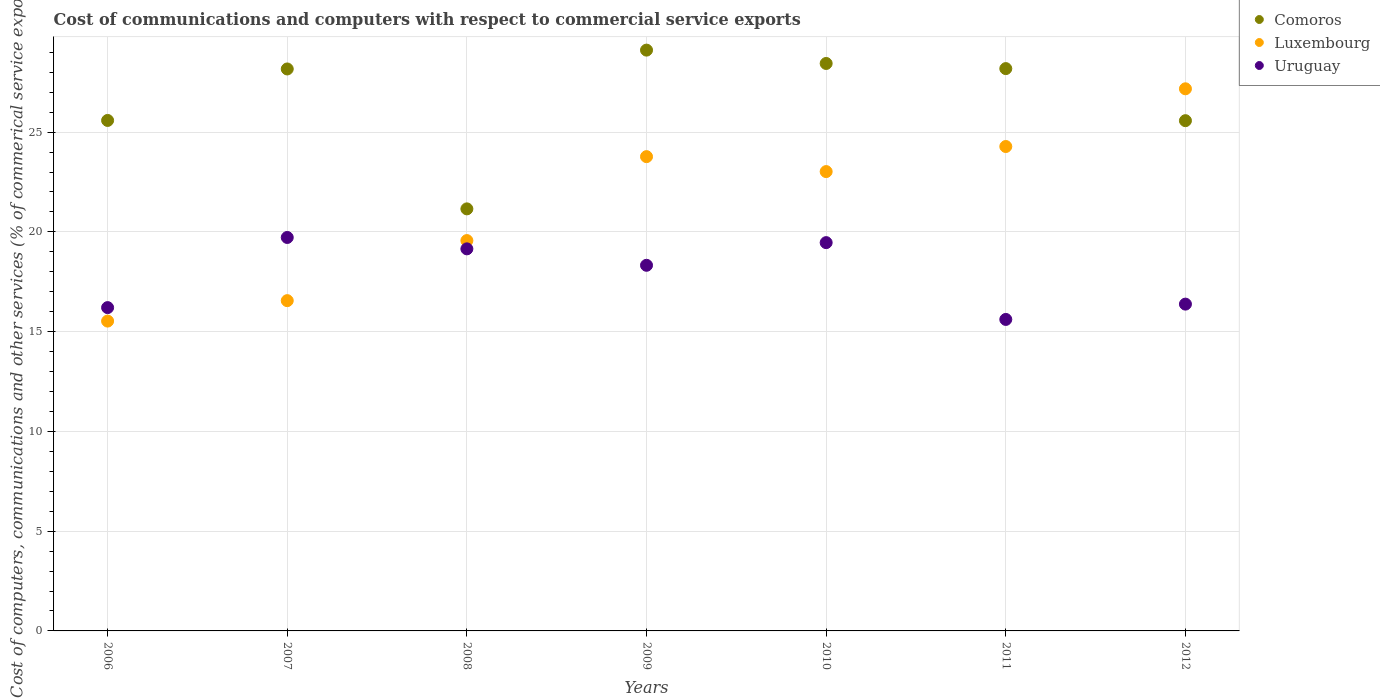What is the cost of communications and computers in Comoros in 2010?
Your answer should be compact. 28.44. Across all years, what is the maximum cost of communications and computers in Luxembourg?
Offer a very short reply. 27.17. Across all years, what is the minimum cost of communications and computers in Luxembourg?
Keep it short and to the point. 15.53. In which year was the cost of communications and computers in Uruguay maximum?
Your response must be concise. 2007. What is the total cost of communications and computers in Luxembourg in the graph?
Provide a short and direct response. 149.89. What is the difference between the cost of communications and computers in Uruguay in 2008 and that in 2011?
Your answer should be very brief. 3.54. What is the difference between the cost of communications and computers in Uruguay in 2009 and the cost of communications and computers in Comoros in 2008?
Provide a short and direct response. -2.83. What is the average cost of communications and computers in Comoros per year?
Your response must be concise. 26.6. In the year 2010, what is the difference between the cost of communications and computers in Uruguay and cost of communications and computers in Luxembourg?
Provide a succinct answer. -3.56. What is the ratio of the cost of communications and computers in Luxembourg in 2011 to that in 2012?
Offer a very short reply. 0.89. Is the cost of communications and computers in Luxembourg in 2011 less than that in 2012?
Make the answer very short. Yes. What is the difference between the highest and the second highest cost of communications and computers in Luxembourg?
Your answer should be very brief. 2.89. What is the difference between the highest and the lowest cost of communications and computers in Luxembourg?
Offer a very short reply. 11.64. Is the sum of the cost of communications and computers in Comoros in 2011 and 2012 greater than the maximum cost of communications and computers in Uruguay across all years?
Keep it short and to the point. Yes. Does the cost of communications and computers in Uruguay monotonically increase over the years?
Your answer should be very brief. No. Is the cost of communications and computers in Comoros strictly greater than the cost of communications and computers in Luxembourg over the years?
Your answer should be very brief. No. Is the cost of communications and computers in Comoros strictly less than the cost of communications and computers in Uruguay over the years?
Make the answer very short. No. How many dotlines are there?
Give a very brief answer. 3. How many years are there in the graph?
Provide a short and direct response. 7. What is the difference between two consecutive major ticks on the Y-axis?
Make the answer very short. 5. Are the values on the major ticks of Y-axis written in scientific E-notation?
Your response must be concise. No. Does the graph contain any zero values?
Provide a succinct answer. No. Where does the legend appear in the graph?
Make the answer very short. Top right. How many legend labels are there?
Give a very brief answer. 3. What is the title of the graph?
Ensure brevity in your answer.  Cost of communications and computers with respect to commercial service exports. What is the label or title of the X-axis?
Provide a succinct answer. Years. What is the label or title of the Y-axis?
Offer a very short reply. Cost of computers, communications and other services (% of commerical service exports). What is the Cost of computers, communications and other services (% of commerical service exports) in Comoros in 2006?
Provide a short and direct response. 25.59. What is the Cost of computers, communications and other services (% of commerical service exports) of Luxembourg in 2006?
Offer a very short reply. 15.53. What is the Cost of computers, communications and other services (% of commerical service exports) in Uruguay in 2006?
Your answer should be very brief. 16.2. What is the Cost of computers, communications and other services (% of commerical service exports) in Comoros in 2007?
Your response must be concise. 28.17. What is the Cost of computers, communications and other services (% of commerical service exports) of Luxembourg in 2007?
Keep it short and to the point. 16.55. What is the Cost of computers, communications and other services (% of commerical service exports) in Uruguay in 2007?
Offer a terse response. 19.72. What is the Cost of computers, communications and other services (% of commerical service exports) of Comoros in 2008?
Provide a short and direct response. 21.15. What is the Cost of computers, communications and other services (% of commerical service exports) of Luxembourg in 2008?
Ensure brevity in your answer.  19.56. What is the Cost of computers, communications and other services (% of commerical service exports) of Uruguay in 2008?
Provide a short and direct response. 19.15. What is the Cost of computers, communications and other services (% of commerical service exports) of Comoros in 2009?
Your answer should be very brief. 29.11. What is the Cost of computers, communications and other services (% of commerical service exports) of Luxembourg in 2009?
Your answer should be compact. 23.77. What is the Cost of computers, communications and other services (% of commerical service exports) in Uruguay in 2009?
Your response must be concise. 18.33. What is the Cost of computers, communications and other services (% of commerical service exports) of Comoros in 2010?
Ensure brevity in your answer.  28.44. What is the Cost of computers, communications and other services (% of commerical service exports) of Luxembourg in 2010?
Provide a succinct answer. 23.02. What is the Cost of computers, communications and other services (% of commerical service exports) of Uruguay in 2010?
Provide a succinct answer. 19.46. What is the Cost of computers, communications and other services (% of commerical service exports) in Comoros in 2011?
Your answer should be compact. 28.18. What is the Cost of computers, communications and other services (% of commerical service exports) of Luxembourg in 2011?
Offer a very short reply. 24.28. What is the Cost of computers, communications and other services (% of commerical service exports) of Uruguay in 2011?
Provide a succinct answer. 15.61. What is the Cost of computers, communications and other services (% of commerical service exports) in Comoros in 2012?
Give a very brief answer. 25.57. What is the Cost of computers, communications and other services (% of commerical service exports) of Luxembourg in 2012?
Provide a short and direct response. 27.17. What is the Cost of computers, communications and other services (% of commerical service exports) of Uruguay in 2012?
Make the answer very short. 16.38. Across all years, what is the maximum Cost of computers, communications and other services (% of commerical service exports) of Comoros?
Your response must be concise. 29.11. Across all years, what is the maximum Cost of computers, communications and other services (% of commerical service exports) in Luxembourg?
Offer a terse response. 27.17. Across all years, what is the maximum Cost of computers, communications and other services (% of commerical service exports) in Uruguay?
Provide a succinct answer. 19.72. Across all years, what is the minimum Cost of computers, communications and other services (% of commerical service exports) in Comoros?
Your answer should be very brief. 21.15. Across all years, what is the minimum Cost of computers, communications and other services (% of commerical service exports) in Luxembourg?
Keep it short and to the point. 15.53. Across all years, what is the minimum Cost of computers, communications and other services (% of commerical service exports) in Uruguay?
Keep it short and to the point. 15.61. What is the total Cost of computers, communications and other services (% of commerical service exports) of Comoros in the graph?
Give a very brief answer. 186.21. What is the total Cost of computers, communications and other services (% of commerical service exports) of Luxembourg in the graph?
Make the answer very short. 149.89. What is the total Cost of computers, communications and other services (% of commerical service exports) of Uruguay in the graph?
Give a very brief answer. 124.85. What is the difference between the Cost of computers, communications and other services (% of commerical service exports) in Comoros in 2006 and that in 2007?
Keep it short and to the point. -2.58. What is the difference between the Cost of computers, communications and other services (% of commerical service exports) of Luxembourg in 2006 and that in 2007?
Your response must be concise. -1.02. What is the difference between the Cost of computers, communications and other services (% of commerical service exports) of Uruguay in 2006 and that in 2007?
Your answer should be very brief. -3.52. What is the difference between the Cost of computers, communications and other services (% of commerical service exports) of Comoros in 2006 and that in 2008?
Give a very brief answer. 4.43. What is the difference between the Cost of computers, communications and other services (% of commerical service exports) in Luxembourg in 2006 and that in 2008?
Offer a very short reply. -4.04. What is the difference between the Cost of computers, communications and other services (% of commerical service exports) of Uruguay in 2006 and that in 2008?
Your answer should be compact. -2.94. What is the difference between the Cost of computers, communications and other services (% of commerical service exports) in Comoros in 2006 and that in 2009?
Give a very brief answer. -3.52. What is the difference between the Cost of computers, communications and other services (% of commerical service exports) in Luxembourg in 2006 and that in 2009?
Offer a terse response. -8.24. What is the difference between the Cost of computers, communications and other services (% of commerical service exports) of Uruguay in 2006 and that in 2009?
Offer a terse response. -2.12. What is the difference between the Cost of computers, communications and other services (% of commerical service exports) in Comoros in 2006 and that in 2010?
Your answer should be compact. -2.86. What is the difference between the Cost of computers, communications and other services (% of commerical service exports) of Luxembourg in 2006 and that in 2010?
Your answer should be very brief. -7.49. What is the difference between the Cost of computers, communications and other services (% of commerical service exports) in Uruguay in 2006 and that in 2010?
Give a very brief answer. -3.26. What is the difference between the Cost of computers, communications and other services (% of commerical service exports) of Comoros in 2006 and that in 2011?
Provide a succinct answer. -2.6. What is the difference between the Cost of computers, communications and other services (% of commerical service exports) of Luxembourg in 2006 and that in 2011?
Your answer should be very brief. -8.75. What is the difference between the Cost of computers, communications and other services (% of commerical service exports) of Uruguay in 2006 and that in 2011?
Offer a terse response. 0.59. What is the difference between the Cost of computers, communications and other services (% of commerical service exports) of Comoros in 2006 and that in 2012?
Provide a succinct answer. 0.01. What is the difference between the Cost of computers, communications and other services (% of commerical service exports) of Luxembourg in 2006 and that in 2012?
Ensure brevity in your answer.  -11.64. What is the difference between the Cost of computers, communications and other services (% of commerical service exports) of Uruguay in 2006 and that in 2012?
Ensure brevity in your answer.  -0.17. What is the difference between the Cost of computers, communications and other services (% of commerical service exports) in Comoros in 2007 and that in 2008?
Provide a succinct answer. 7.01. What is the difference between the Cost of computers, communications and other services (% of commerical service exports) of Luxembourg in 2007 and that in 2008?
Offer a terse response. -3.01. What is the difference between the Cost of computers, communications and other services (% of commerical service exports) in Uruguay in 2007 and that in 2008?
Ensure brevity in your answer.  0.57. What is the difference between the Cost of computers, communications and other services (% of commerical service exports) of Comoros in 2007 and that in 2009?
Your response must be concise. -0.94. What is the difference between the Cost of computers, communications and other services (% of commerical service exports) of Luxembourg in 2007 and that in 2009?
Provide a short and direct response. -7.22. What is the difference between the Cost of computers, communications and other services (% of commerical service exports) in Uruguay in 2007 and that in 2009?
Offer a very short reply. 1.39. What is the difference between the Cost of computers, communications and other services (% of commerical service exports) of Comoros in 2007 and that in 2010?
Keep it short and to the point. -0.28. What is the difference between the Cost of computers, communications and other services (% of commerical service exports) of Luxembourg in 2007 and that in 2010?
Provide a succinct answer. -6.47. What is the difference between the Cost of computers, communications and other services (% of commerical service exports) of Uruguay in 2007 and that in 2010?
Offer a terse response. 0.26. What is the difference between the Cost of computers, communications and other services (% of commerical service exports) in Comoros in 2007 and that in 2011?
Keep it short and to the point. -0.02. What is the difference between the Cost of computers, communications and other services (% of commerical service exports) in Luxembourg in 2007 and that in 2011?
Keep it short and to the point. -7.73. What is the difference between the Cost of computers, communications and other services (% of commerical service exports) in Uruguay in 2007 and that in 2011?
Give a very brief answer. 4.11. What is the difference between the Cost of computers, communications and other services (% of commerical service exports) in Comoros in 2007 and that in 2012?
Your response must be concise. 2.59. What is the difference between the Cost of computers, communications and other services (% of commerical service exports) of Luxembourg in 2007 and that in 2012?
Make the answer very short. -10.62. What is the difference between the Cost of computers, communications and other services (% of commerical service exports) in Uruguay in 2007 and that in 2012?
Offer a terse response. 3.34. What is the difference between the Cost of computers, communications and other services (% of commerical service exports) of Comoros in 2008 and that in 2009?
Give a very brief answer. -7.96. What is the difference between the Cost of computers, communications and other services (% of commerical service exports) in Luxembourg in 2008 and that in 2009?
Offer a terse response. -4.21. What is the difference between the Cost of computers, communications and other services (% of commerical service exports) of Uruguay in 2008 and that in 2009?
Offer a terse response. 0.82. What is the difference between the Cost of computers, communications and other services (% of commerical service exports) of Comoros in 2008 and that in 2010?
Provide a succinct answer. -7.29. What is the difference between the Cost of computers, communications and other services (% of commerical service exports) of Luxembourg in 2008 and that in 2010?
Ensure brevity in your answer.  -3.46. What is the difference between the Cost of computers, communications and other services (% of commerical service exports) in Uruguay in 2008 and that in 2010?
Your answer should be very brief. -0.31. What is the difference between the Cost of computers, communications and other services (% of commerical service exports) of Comoros in 2008 and that in 2011?
Keep it short and to the point. -7.03. What is the difference between the Cost of computers, communications and other services (% of commerical service exports) of Luxembourg in 2008 and that in 2011?
Make the answer very short. -4.71. What is the difference between the Cost of computers, communications and other services (% of commerical service exports) of Uruguay in 2008 and that in 2011?
Your answer should be very brief. 3.54. What is the difference between the Cost of computers, communications and other services (% of commerical service exports) of Comoros in 2008 and that in 2012?
Make the answer very short. -4.42. What is the difference between the Cost of computers, communications and other services (% of commerical service exports) of Luxembourg in 2008 and that in 2012?
Your response must be concise. -7.61. What is the difference between the Cost of computers, communications and other services (% of commerical service exports) in Uruguay in 2008 and that in 2012?
Make the answer very short. 2.77. What is the difference between the Cost of computers, communications and other services (% of commerical service exports) of Comoros in 2009 and that in 2010?
Provide a succinct answer. 0.67. What is the difference between the Cost of computers, communications and other services (% of commerical service exports) of Luxembourg in 2009 and that in 2010?
Your response must be concise. 0.75. What is the difference between the Cost of computers, communications and other services (% of commerical service exports) of Uruguay in 2009 and that in 2010?
Your answer should be compact. -1.14. What is the difference between the Cost of computers, communications and other services (% of commerical service exports) in Comoros in 2009 and that in 2011?
Your response must be concise. 0.93. What is the difference between the Cost of computers, communications and other services (% of commerical service exports) of Luxembourg in 2009 and that in 2011?
Your answer should be very brief. -0.51. What is the difference between the Cost of computers, communications and other services (% of commerical service exports) in Uruguay in 2009 and that in 2011?
Your response must be concise. 2.71. What is the difference between the Cost of computers, communications and other services (% of commerical service exports) in Comoros in 2009 and that in 2012?
Offer a very short reply. 3.54. What is the difference between the Cost of computers, communications and other services (% of commerical service exports) in Luxembourg in 2009 and that in 2012?
Offer a very short reply. -3.4. What is the difference between the Cost of computers, communications and other services (% of commerical service exports) of Uruguay in 2009 and that in 2012?
Your answer should be very brief. 1.95. What is the difference between the Cost of computers, communications and other services (% of commerical service exports) of Comoros in 2010 and that in 2011?
Ensure brevity in your answer.  0.26. What is the difference between the Cost of computers, communications and other services (% of commerical service exports) of Luxembourg in 2010 and that in 2011?
Provide a short and direct response. -1.26. What is the difference between the Cost of computers, communications and other services (% of commerical service exports) in Uruguay in 2010 and that in 2011?
Provide a short and direct response. 3.85. What is the difference between the Cost of computers, communications and other services (% of commerical service exports) of Comoros in 2010 and that in 2012?
Offer a very short reply. 2.87. What is the difference between the Cost of computers, communications and other services (% of commerical service exports) of Luxembourg in 2010 and that in 2012?
Keep it short and to the point. -4.15. What is the difference between the Cost of computers, communications and other services (% of commerical service exports) in Uruguay in 2010 and that in 2012?
Offer a terse response. 3.08. What is the difference between the Cost of computers, communications and other services (% of commerical service exports) of Comoros in 2011 and that in 2012?
Make the answer very short. 2.61. What is the difference between the Cost of computers, communications and other services (% of commerical service exports) in Luxembourg in 2011 and that in 2012?
Give a very brief answer. -2.89. What is the difference between the Cost of computers, communications and other services (% of commerical service exports) in Uruguay in 2011 and that in 2012?
Offer a very short reply. -0.77. What is the difference between the Cost of computers, communications and other services (% of commerical service exports) of Comoros in 2006 and the Cost of computers, communications and other services (% of commerical service exports) of Luxembourg in 2007?
Offer a terse response. 9.03. What is the difference between the Cost of computers, communications and other services (% of commerical service exports) of Comoros in 2006 and the Cost of computers, communications and other services (% of commerical service exports) of Uruguay in 2007?
Make the answer very short. 5.87. What is the difference between the Cost of computers, communications and other services (% of commerical service exports) in Luxembourg in 2006 and the Cost of computers, communications and other services (% of commerical service exports) in Uruguay in 2007?
Offer a terse response. -4.19. What is the difference between the Cost of computers, communications and other services (% of commerical service exports) in Comoros in 2006 and the Cost of computers, communications and other services (% of commerical service exports) in Luxembourg in 2008?
Your response must be concise. 6.02. What is the difference between the Cost of computers, communications and other services (% of commerical service exports) of Comoros in 2006 and the Cost of computers, communications and other services (% of commerical service exports) of Uruguay in 2008?
Ensure brevity in your answer.  6.44. What is the difference between the Cost of computers, communications and other services (% of commerical service exports) of Luxembourg in 2006 and the Cost of computers, communications and other services (% of commerical service exports) of Uruguay in 2008?
Provide a short and direct response. -3.62. What is the difference between the Cost of computers, communications and other services (% of commerical service exports) of Comoros in 2006 and the Cost of computers, communications and other services (% of commerical service exports) of Luxembourg in 2009?
Give a very brief answer. 1.81. What is the difference between the Cost of computers, communications and other services (% of commerical service exports) of Comoros in 2006 and the Cost of computers, communications and other services (% of commerical service exports) of Uruguay in 2009?
Provide a succinct answer. 7.26. What is the difference between the Cost of computers, communications and other services (% of commerical service exports) in Luxembourg in 2006 and the Cost of computers, communications and other services (% of commerical service exports) in Uruguay in 2009?
Provide a short and direct response. -2.8. What is the difference between the Cost of computers, communications and other services (% of commerical service exports) in Comoros in 2006 and the Cost of computers, communications and other services (% of commerical service exports) in Luxembourg in 2010?
Your response must be concise. 2.56. What is the difference between the Cost of computers, communications and other services (% of commerical service exports) of Comoros in 2006 and the Cost of computers, communications and other services (% of commerical service exports) of Uruguay in 2010?
Keep it short and to the point. 6.12. What is the difference between the Cost of computers, communications and other services (% of commerical service exports) in Luxembourg in 2006 and the Cost of computers, communications and other services (% of commerical service exports) in Uruguay in 2010?
Ensure brevity in your answer.  -3.93. What is the difference between the Cost of computers, communications and other services (% of commerical service exports) in Comoros in 2006 and the Cost of computers, communications and other services (% of commerical service exports) in Luxembourg in 2011?
Ensure brevity in your answer.  1.31. What is the difference between the Cost of computers, communications and other services (% of commerical service exports) in Comoros in 2006 and the Cost of computers, communications and other services (% of commerical service exports) in Uruguay in 2011?
Keep it short and to the point. 9.97. What is the difference between the Cost of computers, communications and other services (% of commerical service exports) in Luxembourg in 2006 and the Cost of computers, communications and other services (% of commerical service exports) in Uruguay in 2011?
Provide a short and direct response. -0.08. What is the difference between the Cost of computers, communications and other services (% of commerical service exports) in Comoros in 2006 and the Cost of computers, communications and other services (% of commerical service exports) in Luxembourg in 2012?
Provide a succinct answer. -1.59. What is the difference between the Cost of computers, communications and other services (% of commerical service exports) in Comoros in 2006 and the Cost of computers, communications and other services (% of commerical service exports) in Uruguay in 2012?
Make the answer very short. 9.21. What is the difference between the Cost of computers, communications and other services (% of commerical service exports) in Luxembourg in 2006 and the Cost of computers, communications and other services (% of commerical service exports) in Uruguay in 2012?
Your answer should be compact. -0.85. What is the difference between the Cost of computers, communications and other services (% of commerical service exports) in Comoros in 2007 and the Cost of computers, communications and other services (% of commerical service exports) in Luxembourg in 2008?
Give a very brief answer. 8.6. What is the difference between the Cost of computers, communications and other services (% of commerical service exports) of Comoros in 2007 and the Cost of computers, communications and other services (% of commerical service exports) of Uruguay in 2008?
Ensure brevity in your answer.  9.02. What is the difference between the Cost of computers, communications and other services (% of commerical service exports) of Luxembourg in 2007 and the Cost of computers, communications and other services (% of commerical service exports) of Uruguay in 2008?
Your answer should be very brief. -2.6. What is the difference between the Cost of computers, communications and other services (% of commerical service exports) of Comoros in 2007 and the Cost of computers, communications and other services (% of commerical service exports) of Luxembourg in 2009?
Make the answer very short. 4.39. What is the difference between the Cost of computers, communications and other services (% of commerical service exports) of Comoros in 2007 and the Cost of computers, communications and other services (% of commerical service exports) of Uruguay in 2009?
Your response must be concise. 9.84. What is the difference between the Cost of computers, communications and other services (% of commerical service exports) of Luxembourg in 2007 and the Cost of computers, communications and other services (% of commerical service exports) of Uruguay in 2009?
Your answer should be compact. -1.77. What is the difference between the Cost of computers, communications and other services (% of commerical service exports) in Comoros in 2007 and the Cost of computers, communications and other services (% of commerical service exports) in Luxembourg in 2010?
Make the answer very short. 5.14. What is the difference between the Cost of computers, communications and other services (% of commerical service exports) in Comoros in 2007 and the Cost of computers, communications and other services (% of commerical service exports) in Uruguay in 2010?
Give a very brief answer. 8.7. What is the difference between the Cost of computers, communications and other services (% of commerical service exports) in Luxembourg in 2007 and the Cost of computers, communications and other services (% of commerical service exports) in Uruguay in 2010?
Provide a short and direct response. -2.91. What is the difference between the Cost of computers, communications and other services (% of commerical service exports) of Comoros in 2007 and the Cost of computers, communications and other services (% of commerical service exports) of Luxembourg in 2011?
Keep it short and to the point. 3.89. What is the difference between the Cost of computers, communications and other services (% of commerical service exports) of Comoros in 2007 and the Cost of computers, communications and other services (% of commerical service exports) of Uruguay in 2011?
Your answer should be very brief. 12.55. What is the difference between the Cost of computers, communications and other services (% of commerical service exports) of Luxembourg in 2007 and the Cost of computers, communications and other services (% of commerical service exports) of Uruguay in 2011?
Keep it short and to the point. 0.94. What is the difference between the Cost of computers, communications and other services (% of commerical service exports) of Comoros in 2007 and the Cost of computers, communications and other services (% of commerical service exports) of Uruguay in 2012?
Make the answer very short. 11.79. What is the difference between the Cost of computers, communications and other services (% of commerical service exports) of Luxembourg in 2007 and the Cost of computers, communications and other services (% of commerical service exports) of Uruguay in 2012?
Your answer should be compact. 0.17. What is the difference between the Cost of computers, communications and other services (% of commerical service exports) of Comoros in 2008 and the Cost of computers, communications and other services (% of commerical service exports) of Luxembourg in 2009?
Keep it short and to the point. -2.62. What is the difference between the Cost of computers, communications and other services (% of commerical service exports) in Comoros in 2008 and the Cost of computers, communications and other services (% of commerical service exports) in Uruguay in 2009?
Provide a succinct answer. 2.83. What is the difference between the Cost of computers, communications and other services (% of commerical service exports) of Luxembourg in 2008 and the Cost of computers, communications and other services (% of commerical service exports) of Uruguay in 2009?
Ensure brevity in your answer.  1.24. What is the difference between the Cost of computers, communications and other services (% of commerical service exports) of Comoros in 2008 and the Cost of computers, communications and other services (% of commerical service exports) of Luxembourg in 2010?
Ensure brevity in your answer.  -1.87. What is the difference between the Cost of computers, communications and other services (% of commerical service exports) of Comoros in 2008 and the Cost of computers, communications and other services (% of commerical service exports) of Uruguay in 2010?
Your answer should be very brief. 1.69. What is the difference between the Cost of computers, communications and other services (% of commerical service exports) of Luxembourg in 2008 and the Cost of computers, communications and other services (% of commerical service exports) of Uruguay in 2010?
Provide a succinct answer. 0.1. What is the difference between the Cost of computers, communications and other services (% of commerical service exports) in Comoros in 2008 and the Cost of computers, communications and other services (% of commerical service exports) in Luxembourg in 2011?
Your response must be concise. -3.13. What is the difference between the Cost of computers, communications and other services (% of commerical service exports) of Comoros in 2008 and the Cost of computers, communications and other services (% of commerical service exports) of Uruguay in 2011?
Give a very brief answer. 5.54. What is the difference between the Cost of computers, communications and other services (% of commerical service exports) in Luxembourg in 2008 and the Cost of computers, communications and other services (% of commerical service exports) in Uruguay in 2011?
Give a very brief answer. 3.95. What is the difference between the Cost of computers, communications and other services (% of commerical service exports) of Comoros in 2008 and the Cost of computers, communications and other services (% of commerical service exports) of Luxembourg in 2012?
Offer a very short reply. -6.02. What is the difference between the Cost of computers, communications and other services (% of commerical service exports) of Comoros in 2008 and the Cost of computers, communications and other services (% of commerical service exports) of Uruguay in 2012?
Offer a terse response. 4.77. What is the difference between the Cost of computers, communications and other services (% of commerical service exports) of Luxembourg in 2008 and the Cost of computers, communications and other services (% of commerical service exports) of Uruguay in 2012?
Offer a very short reply. 3.19. What is the difference between the Cost of computers, communications and other services (% of commerical service exports) of Comoros in 2009 and the Cost of computers, communications and other services (% of commerical service exports) of Luxembourg in 2010?
Your answer should be compact. 6.09. What is the difference between the Cost of computers, communications and other services (% of commerical service exports) of Comoros in 2009 and the Cost of computers, communications and other services (% of commerical service exports) of Uruguay in 2010?
Provide a succinct answer. 9.65. What is the difference between the Cost of computers, communications and other services (% of commerical service exports) in Luxembourg in 2009 and the Cost of computers, communications and other services (% of commerical service exports) in Uruguay in 2010?
Your response must be concise. 4.31. What is the difference between the Cost of computers, communications and other services (% of commerical service exports) of Comoros in 2009 and the Cost of computers, communications and other services (% of commerical service exports) of Luxembourg in 2011?
Provide a short and direct response. 4.83. What is the difference between the Cost of computers, communications and other services (% of commerical service exports) of Comoros in 2009 and the Cost of computers, communications and other services (% of commerical service exports) of Uruguay in 2011?
Offer a terse response. 13.5. What is the difference between the Cost of computers, communications and other services (% of commerical service exports) of Luxembourg in 2009 and the Cost of computers, communications and other services (% of commerical service exports) of Uruguay in 2011?
Keep it short and to the point. 8.16. What is the difference between the Cost of computers, communications and other services (% of commerical service exports) of Comoros in 2009 and the Cost of computers, communications and other services (% of commerical service exports) of Luxembourg in 2012?
Offer a very short reply. 1.94. What is the difference between the Cost of computers, communications and other services (% of commerical service exports) of Comoros in 2009 and the Cost of computers, communications and other services (% of commerical service exports) of Uruguay in 2012?
Ensure brevity in your answer.  12.73. What is the difference between the Cost of computers, communications and other services (% of commerical service exports) in Luxembourg in 2009 and the Cost of computers, communications and other services (% of commerical service exports) in Uruguay in 2012?
Offer a terse response. 7.39. What is the difference between the Cost of computers, communications and other services (% of commerical service exports) of Comoros in 2010 and the Cost of computers, communications and other services (% of commerical service exports) of Luxembourg in 2011?
Ensure brevity in your answer.  4.16. What is the difference between the Cost of computers, communications and other services (% of commerical service exports) of Comoros in 2010 and the Cost of computers, communications and other services (% of commerical service exports) of Uruguay in 2011?
Provide a succinct answer. 12.83. What is the difference between the Cost of computers, communications and other services (% of commerical service exports) in Luxembourg in 2010 and the Cost of computers, communications and other services (% of commerical service exports) in Uruguay in 2011?
Your answer should be very brief. 7.41. What is the difference between the Cost of computers, communications and other services (% of commerical service exports) in Comoros in 2010 and the Cost of computers, communications and other services (% of commerical service exports) in Luxembourg in 2012?
Your answer should be very brief. 1.27. What is the difference between the Cost of computers, communications and other services (% of commerical service exports) in Comoros in 2010 and the Cost of computers, communications and other services (% of commerical service exports) in Uruguay in 2012?
Your answer should be compact. 12.06. What is the difference between the Cost of computers, communications and other services (% of commerical service exports) in Luxembourg in 2010 and the Cost of computers, communications and other services (% of commerical service exports) in Uruguay in 2012?
Your answer should be very brief. 6.64. What is the difference between the Cost of computers, communications and other services (% of commerical service exports) of Comoros in 2011 and the Cost of computers, communications and other services (% of commerical service exports) of Luxembourg in 2012?
Your response must be concise. 1.01. What is the difference between the Cost of computers, communications and other services (% of commerical service exports) of Comoros in 2011 and the Cost of computers, communications and other services (% of commerical service exports) of Uruguay in 2012?
Offer a very short reply. 11.8. What is the difference between the Cost of computers, communications and other services (% of commerical service exports) in Luxembourg in 2011 and the Cost of computers, communications and other services (% of commerical service exports) in Uruguay in 2012?
Your response must be concise. 7.9. What is the average Cost of computers, communications and other services (% of commerical service exports) of Comoros per year?
Offer a terse response. 26.6. What is the average Cost of computers, communications and other services (% of commerical service exports) in Luxembourg per year?
Your answer should be very brief. 21.41. What is the average Cost of computers, communications and other services (% of commerical service exports) in Uruguay per year?
Your response must be concise. 17.84. In the year 2006, what is the difference between the Cost of computers, communications and other services (% of commerical service exports) of Comoros and Cost of computers, communications and other services (% of commerical service exports) of Luxembourg?
Keep it short and to the point. 10.06. In the year 2006, what is the difference between the Cost of computers, communications and other services (% of commerical service exports) in Comoros and Cost of computers, communications and other services (% of commerical service exports) in Uruguay?
Offer a terse response. 9.38. In the year 2006, what is the difference between the Cost of computers, communications and other services (% of commerical service exports) in Luxembourg and Cost of computers, communications and other services (% of commerical service exports) in Uruguay?
Your answer should be very brief. -0.68. In the year 2007, what is the difference between the Cost of computers, communications and other services (% of commerical service exports) of Comoros and Cost of computers, communications and other services (% of commerical service exports) of Luxembourg?
Provide a succinct answer. 11.61. In the year 2007, what is the difference between the Cost of computers, communications and other services (% of commerical service exports) in Comoros and Cost of computers, communications and other services (% of commerical service exports) in Uruguay?
Your answer should be very brief. 8.45. In the year 2007, what is the difference between the Cost of computers, communications and other services (% of commerical service exports) in Luxembourg and Cost of computers, communications and other services (% of commerical service exports) in Uruguay?
Provide a succinct answer. -3.17. In the year 2008, what is the difference between the Cost of computers, communications and other services (% of commerical service exports) of Comoros and Cost of computers, communications and other services (% of commerical service exports) of Luxembourg?
Your answer should be compact. 1.59. In the year 2008, what is the difference between the Cost of computers, communications and other services (% of commerical service exports) of Comoros and Cost of computers, communications and other services (% of commerical service exports) of Uruguay?
Offer a terse response. 2. In the year 2008, what is the difference between the Cost of computers, communications and other services (% of commerical service exports) in Luxembourg and Cost of computers, communications and other services (% of commerical service exports) in Uruguay?
Your answer should be very brief. 0.41. In the year 2009, what is the difference between the Cost of computers, communications and other services (% of commerical service exports) in Comoros and Cost of computers, communications and other services (% of commerical service exports) in Luxembourg?
Keep it short and to the point. 5.34. In the year 2009, what is the difference between the Cost of computers, communications and other services (% of commerical service exports) in Comoros and Cost of computers, communications and other services (% of commerical service exports) in Uruguay?
Keep it short and to the point. 10.78. In the year 2009, what is the difference between the Cost of computers, communications and other services (% of commerical service exports) in Luxembourg and Cost of computers, communications and other services (% of commerical service exports) in Uruguay?
Your response must be concise. 5.45. In the year 2010, what is the difference between the Cost of computers, communications and other services (% of commerical service exports) in Comoros and Cost of computers, communications and other services (% of commerical service exports) in Luxembourg?
Your response must be concise. 5.42. In the year 2010, what is the difference between the Cost of computers, communications and other services (% of commerical service exports) of Comoros and Cost of computers, communications and other services (% of commerical service exports) of Uruguay?
Your answer should be very brief. 8.98. In the year 2010, what is the difference between the Cost of computers, communications and other services (% of commerical service exports) in Luxembourg and Cost of computers, communications and other services (% of commerical service exports) in Uruguay?
Your answer should be very brief. 3.56. In the year 2011, what is the difference between the Cost of computers, communications and other services (% of commerical service exports) of Comoros and Cost of computers, communications and other services (% of commerical service exports) of Luxembourg?
Give a very brief answer. 3.9. In the year 2011, what is the difference between the Cost of computers, communications and other services (% of commerical service exports) in Comoros and Cost of computers, communications and other services (% of commerical service exports) in Uruguay?
Provide a short and direct response. 12.57. In the year 2011, what is the difference between the Cost of computers, communications and other services (% of commerical service exports) of Luxembourg and Cost of computers, communications and other services (% of commerical service exports) of Uruguay?
Your answer should be compact. 8.67. In the year 2012, what is the difference between the Cost of computers, communications and other services (% of commerical service exports) in Comoros and Cost of computers, communications and other services (% of commerical service exports) in Luxembourg?
Ensure brevity in your answer.  -1.6. In the year 2012, what is the difference between the Cost of computers, communications and other services (% of commerical service exports) in Comoros and Cost of computers, communications and other services (% of commerical service exports) in Uruguay?
Keep it short and to the point. 9.19. In the year 2012, what is the difference between the Cost of computers, communications and other services (% of commerical service exports) of Luxembourg and Cost of computers, communications and other services (% of commerical service exports) of Uruguay?
Keep it short and to the point. 10.79. What is the ratio of the Cost of computers, communications and other services (% of commerical service exports) of Comoros in 2006 to that in 2007?
Your response must be concise. 0.91. What is the ratio of the Cost of computers, communications and other services (% of commerical service exports) of Luxembourg in 2006 to that in 2007?
Your answer should be very brief. 0.94. What is the ratio of the Cost of computers, communications and other services (% of commerical service exports) of Uruguay in 2006 to that in 2007?
Your answer should be very brief. 0.82. What is the ratio of the Cost of computers, communications and other services (% of commerical service exports) in Comoros in 2006 to that in 2008?
Keep it short and to the point. 1.21. What is the ratio of the Cost of computers, communications and other services (% of commerical service exports) in Luxembourg in 2006 to that in 2008?
Offer a terse response. 0.79. What is the ratio of the Cost of computers, communications and other services (% of commerical service exports) in Uruguay in 2006 to that in 2008?
Give a very brief answer. 0.85. What is the ratio of the Cost of computers, communications and other services (% of commerical service exports) in Comoros in 2006 to that in 2009?
Your answer should be very brief. 0.88. What is the ratio of the Cost of computers, communications and other services (% of commerical service exports) of Luxembourg in 2006 to that in 2009?
Give a very brief answer. 0.65. What is the ratio of the Cost of computers, communications and other services (% of commerical service exports) in Uruguay in 2006 to that in 2009?
Provide a short and direct response. 0.88. What is the ratio of the Cost of computers, communications and other services (% of commerical service exports) of Comoros in 2006 to that in 2010?
Your answer should be very brief. 0.9. What is the ratio of the Cost of computers, communications and other services (% of commerical service exports) in Luxembourg in 2006 to that in 2010?
Your answer should be compact. 0.67. What is the ratio of the Cost of computers, communications and other services (% of commerical service exports) in Uruguay in 2006 to that in 2010?
Your response must be concise. 0.83. What is the ratio of the Cost of computers, communications and other services (% of commerical service exports) in Comoros in 2006 to that in 2011?
Give a very brief answer. 0.91. What is the ratio of the Cost of computers, communications and other services (% of commerical service exports) in Luxembourg in 2006 to that in 2011?
Ensure brevity in your answer.  0.64. What is the ratio of the Cost of computers, communications and other services (% of commerical service exports) of Uruguay in 2006 to that in 2011?
Offer a terse response. 1.04. What is the ratio of the Cost of computers, communications and other services (% of commerical service exports) of Comoros in 2006 to that in 2012?
Give a very brief answer. 1. What is the ratio of the Cost of computers, communications and other services (% of commerical service exports) in Luxembourg in 2006 to that in 2012?
Your response must be concise. 0.57. What is the ratio of the Cost of computers, communications and other services (% of commerical service exports) of Uruguay in 2006 to that in 2012?
Make the answer very short. 0.99. What is the ratio of the Cost of computers, communications and other services (% of commerical service exports) in Comoros in 2007 to that in 2008?
Keep it short and to the point. 1.33. What is the ratio of the Cost of computers, communications and other services (% of commerical service exports) of Luxembourg in 2007 to that in 2008?
Keep it short and to the point. 0.85. What is the ratio of the Cost of computers, communications and other services (% of commerical service exports) of Uruguay in 2007 to that in 2008?
Provide a short and direct response. 1.03. What is the ratio of the Cost of computers, communications and other services (% of commerical service exports) in Comoros in 2007 to that in 2009?
Keep it short and to the point. 0.97. What is the ratio of the Cost of computers, communications and other services (% of commerical service exports) in Luxembourg in 2007 to that in 2009?
Provide a short and direct response. 0.7. What is the ratio of the Cost of computers, communications and other services (% of commerical service exports) of Uruguay in 2007 to that in 2009?
Keep it short and to the point. 1.08. What is the ratio of the Cost of computers, communications and other services (% of commerical service exports) in Comoros in 2007 to that in 2010?
Ensure brevity in your answer.  0.99. What is the ratio of the Cost of computers, communications and other services (% of commerical service exports) in Luxembourg in 2007 to that in 2010?
Your response must be concise. 0.72. What is the ratio of the Cost of computers, communications and other services (% of commerical service exports) of Uruguay in 2007 to that in 2010?
Ensure brevity in your answer.  1.01. What is the ratio of the Cost of computers, communications and other services (% of commerical service exports) of Comoros in 2007 to that in 2011?
Your response must be concise. 1. What is the ratio of the Cost of computers, communications and other services (% of commerical service exports) in Luxembourg in 2007 to that in 2011?
Offer a very short reply. 0.68. What is the ratio of the Cost of computers, communications and other services (% of commerical service exports) in Uruguay in 2007 to that in 2011?
Your answer should be very brief. 1.26. What is the ratio of the Cost of computers, communications and other services (% of commerical service exports) in Comoros in 2007 to that in 2012?
Ensure brevity in your answer.  1.1. What is the ratio of the Cost of computers, communications and other services (% of commerical service exports) in Luxembourg in 2007 to that in 2012?
Make the answer very short. 0.61. What is the ratio of the Cost of computers, communications and other services (% of commerical service exports) in Uruguay in 2007 to that in 2012?
Offer a very short reply. 1.2. What is the ratio of the Cost of computers, communications and other services (% of commerical service exports) in Comoros in 2008 to that in 2009?
Provide a short and direct response. 0.73. What is the ratio of the Cost of computers, communications and other services (% of commerical service exports) of Luxembourg in 2008 to that in 2009?
Your response must be concise. 0.82. What is the ratio of the Cost of computers, communications and other services (% of commerical service exports) of Uruguay in 2008 to that in 2009?
Give a very brief answer. 1.04. What is the ratio of the Cost of computers, communications and other services (% of commerical service exports) in Comoros in 2008 to that in 2010?
Make the answer very short. 0.74. What is the ratio of the Cost of computers, communications and other services (% of commerical service exports) in Luxembourg in 2008 to that in 2010?
Give a very brief answer. 0.85. What is the ratio of the Cost of computers, communications and other services (% of commerical service exports) of Comoros in 2008 to that in 2011?
Your answer should be compact. 0.75. What is the ratio of the Cost of computers, communications and other services (% of commerical service exports) of Luxembourg in 2008 to that in 2011?
Offer a terse response. 0.81. What is the ratio of the Cost of computers, communications and other services (% of commerical service exports) in Uruguay in 2008 to that in 2011?
Keep it short and to the point. 1.23. What is the ratio of the Cost of computers, communications and other services (% of commerical service exports) of Comoros in 2008 to that in 2012?
Your response must be concise. 0.83. What is the ratio of the Cost of computers, communications and other services (% of commerical service exports) of Luxembourg in 2008 to that in 2012?
Keep it short and to the point. 0.72. What is the ratio of the Cost of computers, communications and other services (% of commerical service exports) of Uruguay in 2008 to that in 2012?
Offer a terse response. 1.17. What is the ratio of the Cost of computers, communications and other services (% of commerical service exports) in Comoros in 2009 to that in 2010?
Give a very brief answer. 1.02. What is the ratio of the Cost of computers, communications and other services (% of commerical service exports) in Luxembourg in 2009 to that in 2010?
Your answer should be very brief. 1.03. What is the ratio of the Cost of computers, communications and other services (% of commerical service exports) of Uruguay in 2009 to that in 2010?
Your response must be concise. 0.94. What is the ratio of the Cost of computers, communications and other services (% of commerical service exports) in Comoros in 2009 to that in 2011?
Your answer should be compact. 1.03. What is the ratio of the Cost of computers, communications and other services (% of commerical service exports) in Luxembourg in 2009 to that in 2011?
Your answer should be compact. 0.98. What is the ratio of the Cost of computers, communications and other services (% of commerical service exports) in Uruguay in 2009 to that in 2011?
Your answer should be very brief. 1.17. What is the ratio of the Cost of computers, communications and other services (% of commerical service exports) in Comoros in 2009 to that in 2012?
Make the answer very short. 1.14. What is the ratio of the Cost of computers, communications and other services (% of commerical service exports) in Luxembourg in 2009 to that in 2012?
Ensure brevity in your answer.  0.87. What is the ratio of the Cost of computers, communications and other services (% of commerical service exports) of Uruguay in 2009 to that in 2012?
Provide a succinct answer. 1.12. What is the ratio of the Cost of computers, communications and other services (% of commerical service exports) of Comoros in 2010 to that in 2011?
Your answer should be very brief. 1.01. What is the ratio of the Cost of computers, communications and other services (% of commerical service exports) in Luxembourg in 2010 to that in 2011?
Your response must be concise. 0.95. What is the ratio of the Cost of computers, communications and other services (% of commerical service exports) in Uruguay in 2010 to that in 2011?
Make the answer very short. 1.25. What is the ratio of the Cost of computers, communications and other services (% of commerical service exports) in Comoros in 2010 to that in 2012?
Your response must be concise. 1.11. What is the ratio of the Cost of computers, communications and other services (% of commerical service exports) in Luxembourg in 2010 to that in 2012?
Your answer should be compact. 0.85. What is the ratio of the Cost of computers, communications and other services (% of commerical service exports) of Uruguay in 2010 to that in 2012?
Your answer should be very brief. 1.19. What is the ratio of the Cost of computers, communications and other services (% of commerical service exports) of Comoros in 2011 to that in 2012?
Make the answer very short. 1.1. What is the ratio of the Cost of computers, communications and other services (% of commerical service exports) in Luxembourg in 2011 to that in 2012?
Offer a very short reply. 0.89. What is the ratio of the Cost of computers, communications and other services (% of commerical service exports) in Uruguay in 2011 to that in 2012?
Provide a short and direct response. 0.95. What is the difference between the highest and the second highest Cost of computers, communications and other services (% of commerical service exports) in Comoros?
Ensure brevity in your answer.  0.67. What is the difference between the highest and the second highest Cost of computers, communications and other services (% of commerical service exports) of Luxembourg?
Keep it short and to the point. 2.89. What is the difference between the highest and the second highest Cost of computers, communications and other services (% of commerical service exports) in Uruguay?
Make the answer very short. 0.26. What is the difference between the highest and the lowest Cost of computers, communications and other services (% of commerical service exports) in Comoros?
Offer a terse response. 7.96. What is the difference between the highest and the lowest Cost of computers, communications and other services (% of commerical service exports) of Luxembourg?
Offer a very short reply. 11.64. What is the difference between the highest and the lowest Cost of computers, communications and other services (% of commerical service exports) of Uruguay?
Your answer should be compact. 4.11. 